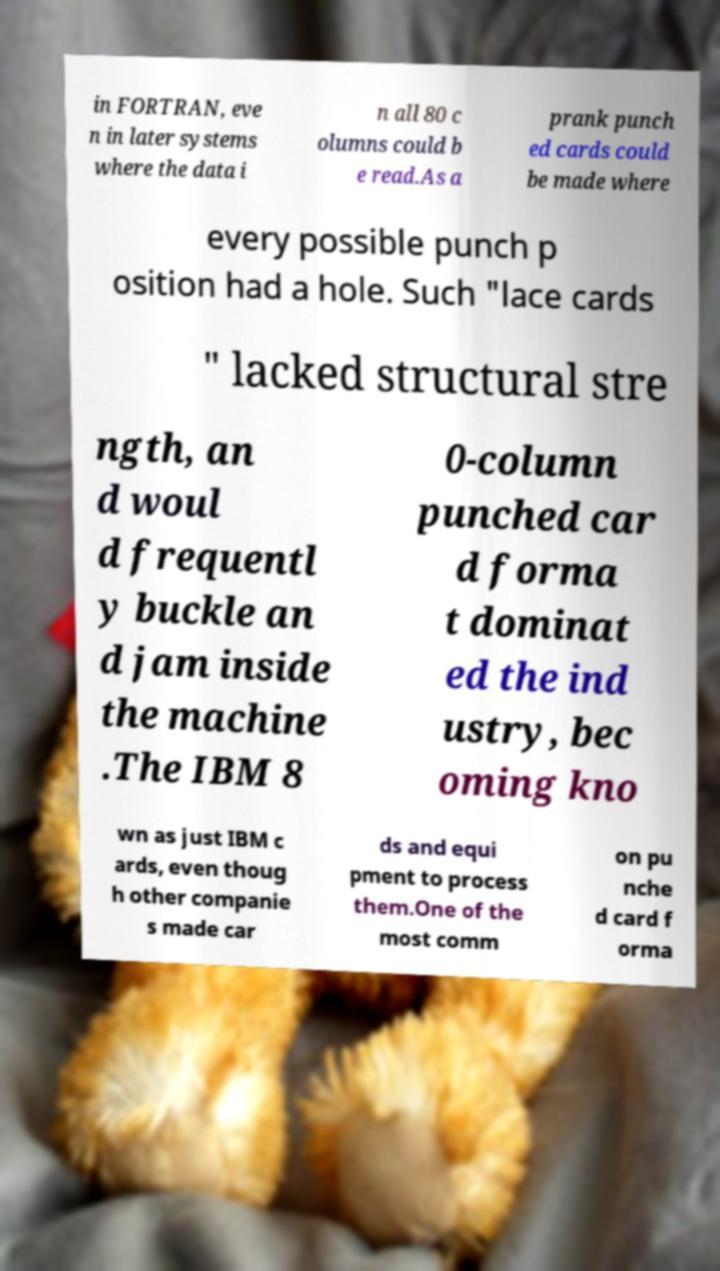Can you read and provide the text displayed in the image?This photo seems to have some interesting text. Can you extract and type it out for me? in FORTRAN, eve n in later systems where the data i n all 80 c olumns could b e read.As a prank punch ed cards could be made where every possible punch p osition had a hole. Such "lace cards " lacked structural stre ngth, an d woul d frequentl y buckle an d jam inside the machine .The IBM 8 0-column punched car d forma t dominat ed the ind ustry, bec oming kno wn as just IBM c ards, even thoug h other companie s made car ds and equi pment to process them.One of the most comm on pu nche d card f orma 